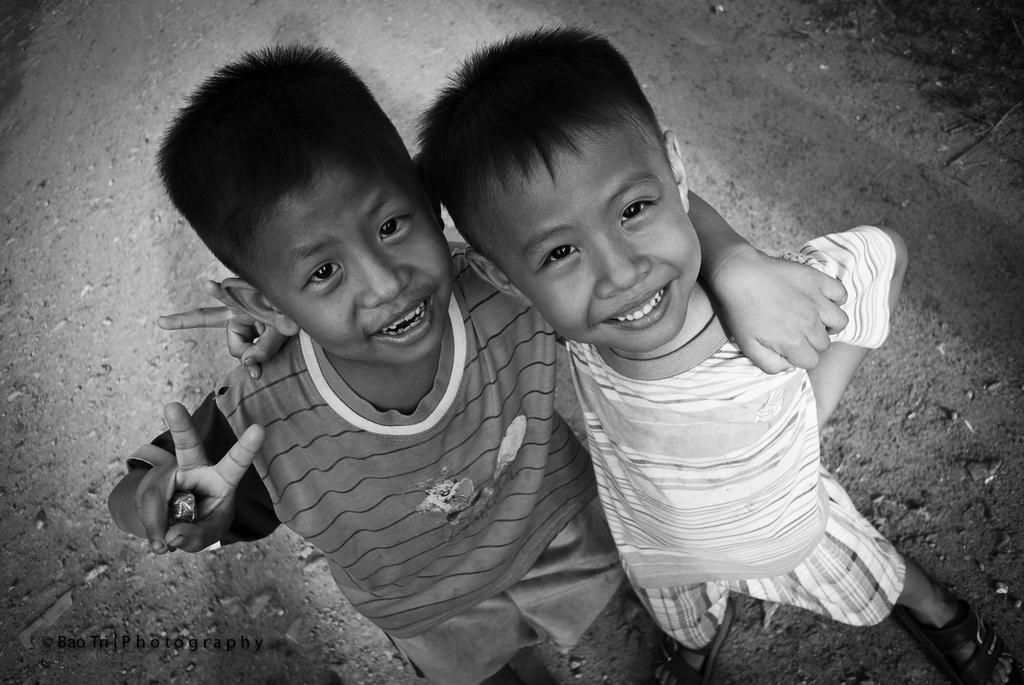Can you describe this image briefly? In this image in the foreground there are two children who are standing and smiling, and at the bottom there is a walkway. 